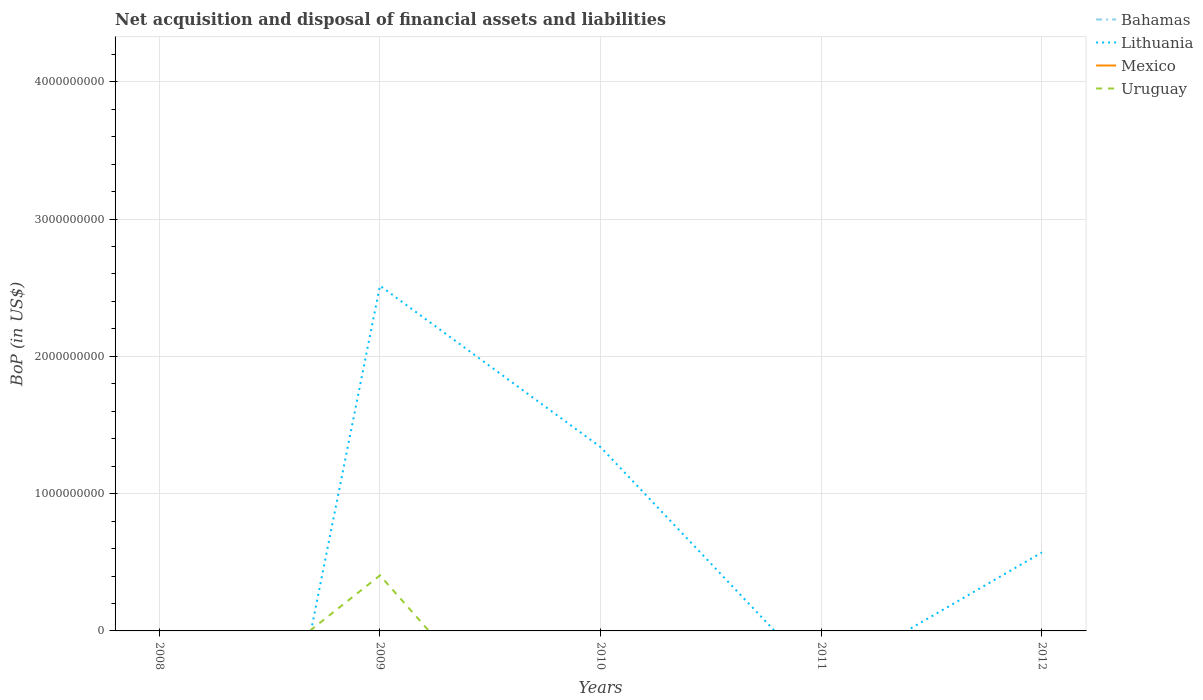Is the number of lines equal to the number of legend labels?
Keep it short and to the point. No. Across all years, what is the maximum Balance of Payments in Bahamas?
Give a very brief answer. 0. What is the difference between the highest and the second highest Balance of Payments in Uruguay?
Provide a short and direct response. 4.04e+08. How many lines are there?
Keep it short and to the point. 2. What is the difference between two consecutive major ticks on the Y-axis?
Give a very brief answer. 1.00e+09. Are the values on the major ticks of Y-axis written in scientific E-notation?
Your response must be concise. No. Does the graph contain any zero values?
Offer a terse response. Yes. How many legend labels are there?
Provide a short and direct response. 4. How are the legend labels stacked?
Provide a succinct answer. Vertical. What is the title of the graph?
Offer a very short reply. Net acquisition and disposal of financial assets and liabilities. Does "Tonga" appear as one of the legend labels in the graph?
Provide a succinct answer. No. What is the label or title of the X-axis?
Offer a terse response. Years. What is the label or title of the Y-axis?
Ensure brevity in your answer.  BoP (in US$). What is the BoP (in US$) of Uruguay in 2008?
Your answer should be compact. 0. What is the BoP (in US$) in Bahamas in 2009?
Offer a very short reply. 0. What is the BoP (in US$) of Lithuania in 2009?
Offer a terse response. 2.51e+09. What is the BoP (in US$) of Mexico in 2009?
Provide a short and direct response. 0. What is the BoP (in US$) in Uruguay in 2009?
Keep it short and to the point. 4.04e+08. What is the BoP (in US$) of Lithuania in 2010?
Give a very brief answer. 1.34e+09. What is the BoP (in US$) of Uruguay in 2010?
Keep it short and to the point. 0. What is the BoP (in US$) of Bahamas in 2011?
Offer a terse response. 0. What is the BoP (in US$) in Lithuania in 2011?
Your answer should be compact. 0. What is the BoP (in US$) in Lithuania in 2012?
Your response must be concise. 5.72e+08. Across all years, what is the maximum BoP (in US$) of Lithuania?
Provide a succinct answer. 2.51e+09. Across all years, what is the maximum BoP (in US$) of Uruguay?
Your response must be concise. 4.04e+08. Across all years, what is the minimum BoP (in US$) in Uruguay?
Offer a very short reply. 0. What is the total BoP (in US$) of Lithuania in the graph?
Offer a terse response. 4.42e+09. What is the total BoP (in US$) in Uruguay in the graph?
Offer a very short reply. 4.04e+08. What is the difference between the BoP (in US$) of Lithuania in 2009 and that in 2010?
Keep it short and to the point. 1.18e+09. What is the difference between the BoP (in US$) in Lithuania in 2009 and that in 2012?
Provide a short and direct response. 1.94e+09. What is the difference between the BoP (in US$) of Lithuania in 2010 and that in 2012?
Give a very brief answer. 7.67e+08. What is the average BoP (in US$) of Bahamas per year?
Keep it short and to the point. 0. What is the average BoP (in US$) in Lithuania per year?
Keep it short and to the point. 8.85e+08. What is the average BoP (in US$) of Uruguay per year?
Your response must be concise. 8.09e+07. In the year 2009, what is the difference between the BoP (in US$) of Lithuania and BoP (in US$) of Uruguay?
Offer a very short reply. 2.11e+09. What is the ratio of the BoP (in US$) of Lithuania in 2009 to that in 2010?
Provide a short and direct response. 1.88. What is the ratio of the BoP (in US$) of Lithuania in 2009 to that in 2012?
Give a very brief answer. 4.4. What is the ratio of the BoP (in US$) of Lithuania in 2010 to that in 2012?
Your answer should be very brief. 2.34. What is the difference between the highest and the second highest BoP (in US$) of Lithuania?
Ensure brevity in your answer.  1.18e+09. What is the difference between the highest and the lowest BoP (in US$) of Lithuania?
Give a very brief answer. 2.51e+09. What is the difference between the highest and the lowest BoP (in US$) in Uruguay?
Your response must be concise. 4.04e+08. 